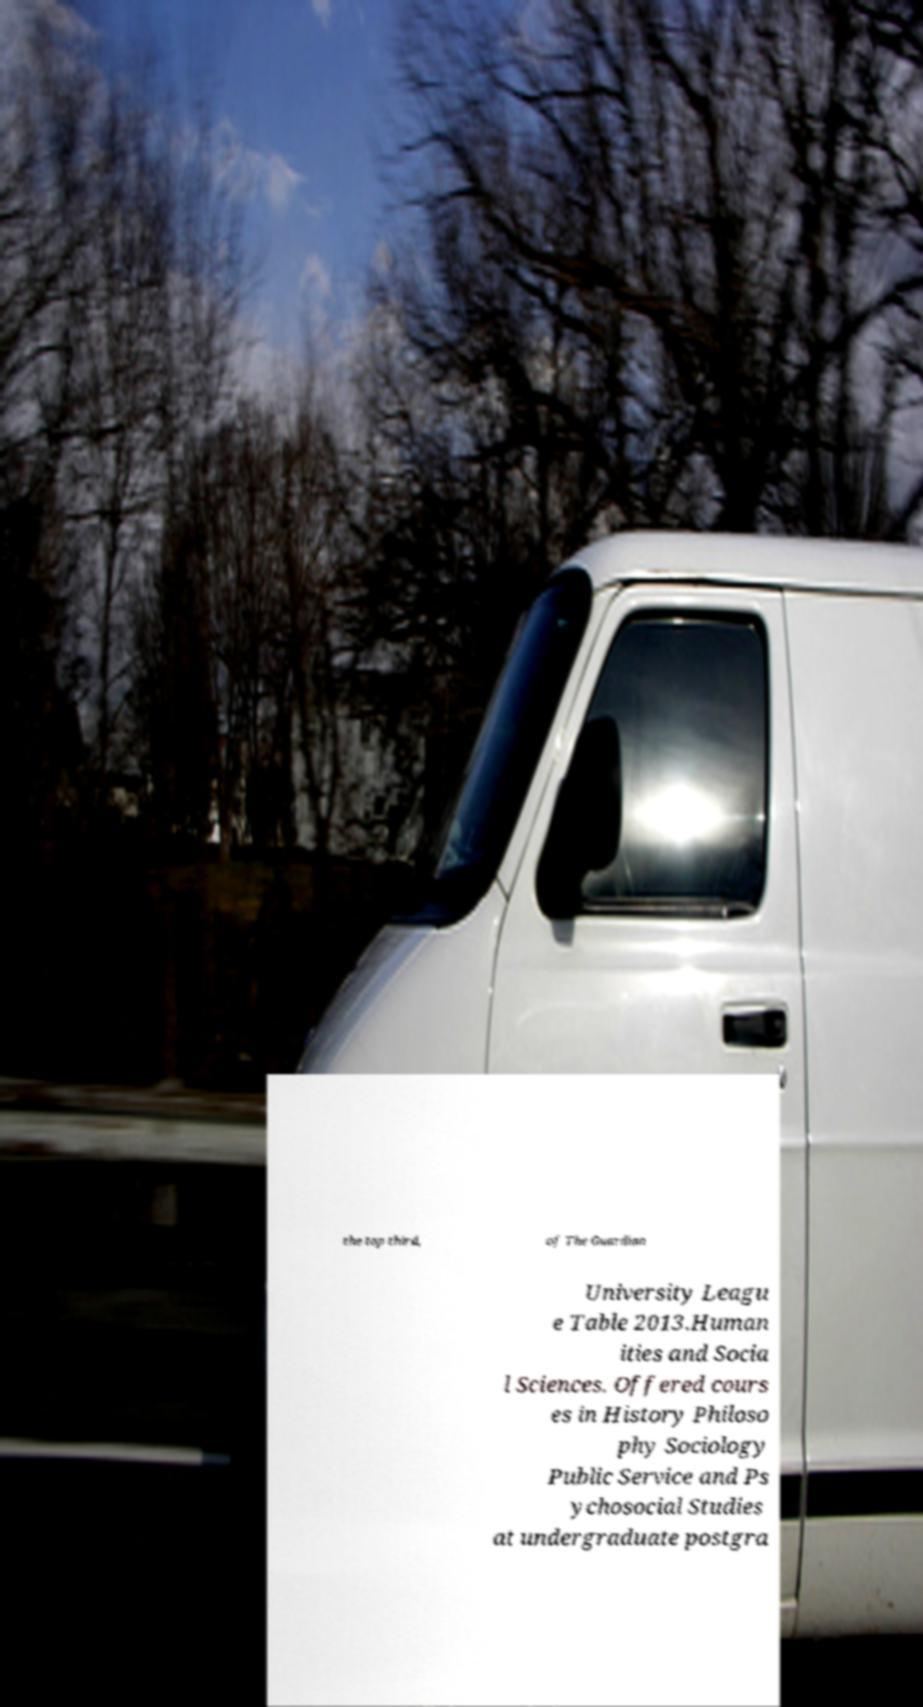Can you accurately transcribe the text from the provided image for me? the top third, of The Guardian University Leagu e Table 2013.Human ities and Socia l Sciences. Offered cours es in History Philoso phy Sociology Public Service and Ps ychosocial Studies at undergraduate postgra 